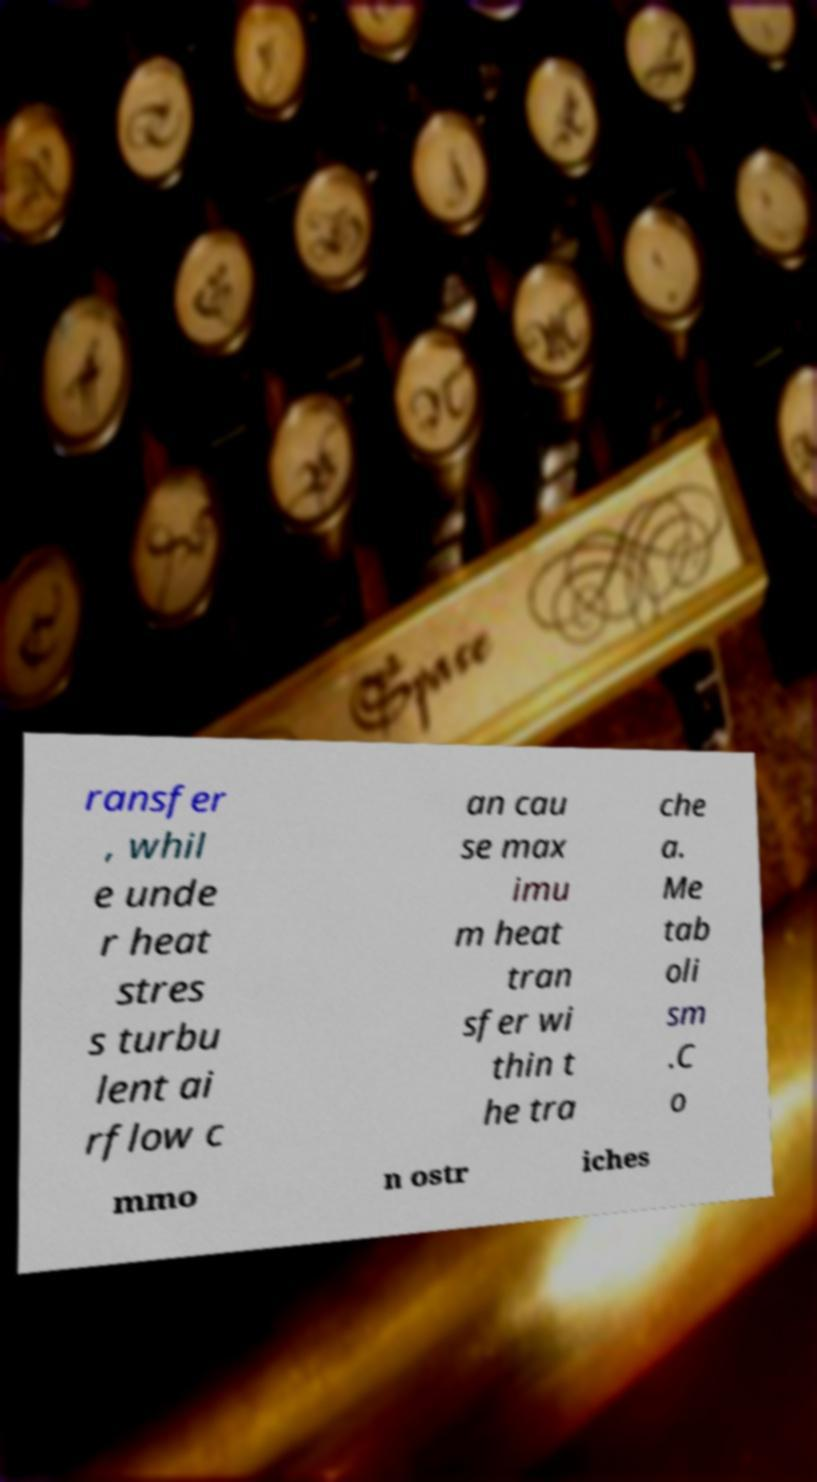I need the written content from this picture converted into text. Can you do that? ransfer , whil e unde r heat stres s turbu lent ai rflow c an cau se max imu m heat tran sfer wi thin t he tra che a. Me tab oli sm .C o mmo n ostr iches 